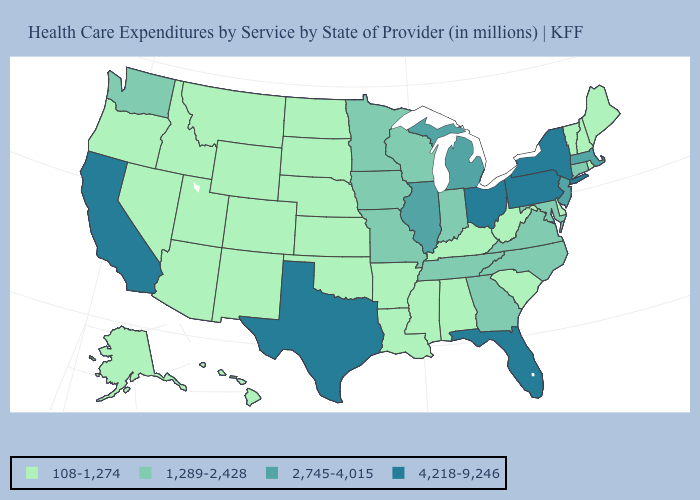Which states have the highest value in the USA?
Be succinct. California, Florida, New York, Ohio, Pennsylvania, Texas. What is the value of New Mexico?
Concise answer only. 108-1,274. Among the states that border New York , which have the lowest value?
Quick response, please. Vermont. Which states have the lowest value in the USA?
Give a very brief answer. Alabama, Alaska, Arizona, Arkansas, Colorado, Delaware, Hawaii, Idaho, Kansas, Kentucky, Louisiana, Maine, Mississippi, Montana, Nebraska, Nevada, New Hampshire, New Mexico, North Dakota, Oklahoma, Oregon, Rhode Island, South Carolina, South Dakota, Utah, Vermont, West Virginia, Wyoming. Name the states that have a value in the range 1,289-2,428?
Answer briefly. Connecticut, Georgia, Indiana, Iowa, Maryland, Minnesota, Missouri, North Carolina, Tennessee, Virginia, Washington, Wisconsin. Name the states that have a value in the range 2,745-4,015?
Keep it brief. Illinois, Massachusetts, Michigan, New Jersey. Which states have the lowest value in the West?
Quick response, please. Alaska, Arizona, Colorado, Hawaii, Idaho, Montana, Nevada, New Mexico, Oregon, Utah, Wyoming. What is the highest value in the USA?
Answer briefly. 4,218-9,246. Name the states that have a value in the range 1,289-2,428?
Be succinct. Connecticut, Georgia, Indiana, Iowa, Maryland, Minnesota, Missouri, North Carolina, Tennessee, Virginia, Washington, Wisconsin. What is the value of New Mexico?
Concise answer only. 108-1,274. Name the states that have a value in the range 108-1,274?
Quick response, please. Alabama, Alaska, Arizona, Arkansas, Colorado, Delaware, Hawaii, Idaho, Kansas, Kentucky, Louisiana, Maine, Mississippi, Montana, Nebraska, Nevada, New Hampshire, New Mexico, North Dakota, Oklahoma, Oregon, Rhode Island, South Carolina, South Dakota, Utah, Vermont, West Virginia, Wyoming. Name the states that have a value in the range 4,218-9,246?
Quick response, please. California, Florida, New York, Ohio, Pennsylvania, Texas. What is the value of Delaware?
Concise answer only. 108-1,274. Does Pennsylvania have the highest value in the USA?
Be succinct. Yes. What is the lowest value in the MidWest?
Answer briefly. 108-1,274. 